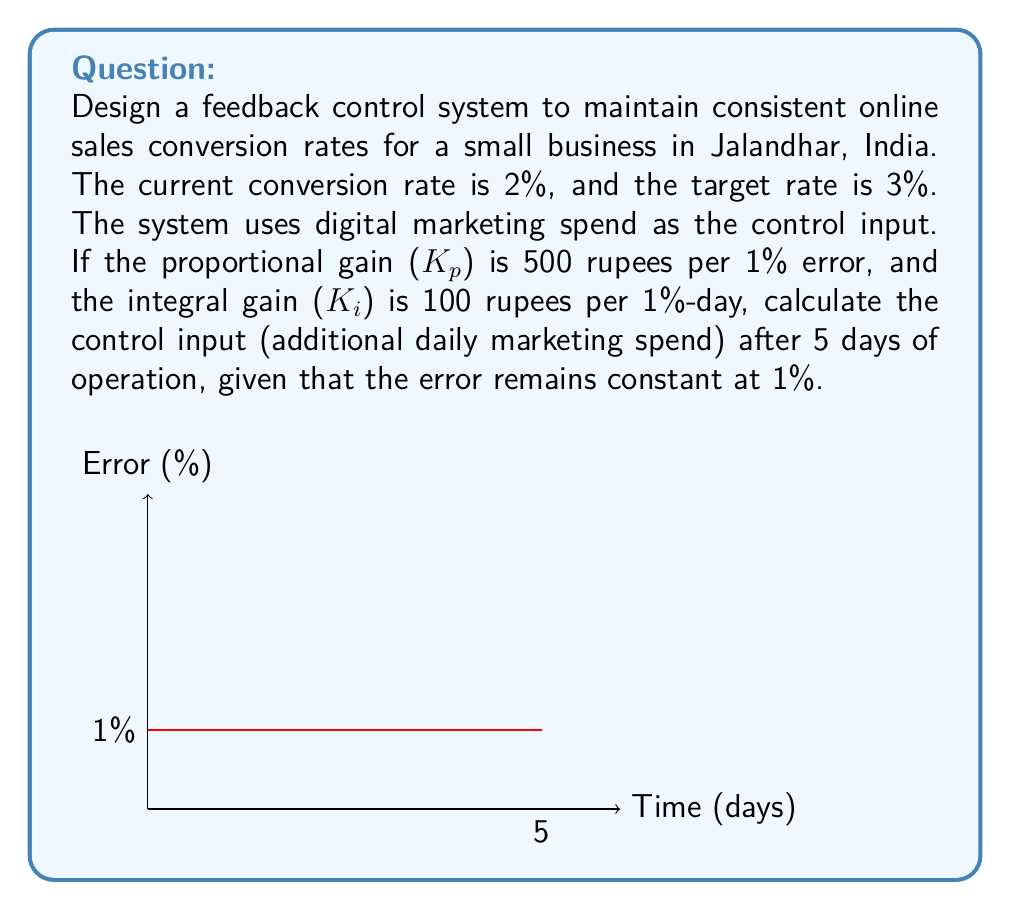Could you help me with this problem? To solve this problem, we'll use the principles of a PI (Proportional-Integral) controller in our feedback control system. The control input u(t) is given by:

$$u(t) = K_p \cdot e(t) + K_i \int_0^t e(\tau) d\tau$$

Where:
- $K_p$ is the proportional gain
- $K_i$ is the integral gain
- $e(t)$ is the error at time t

Given:
- $K_p = 500$ rupees per 1% error
- $K_i = 100$ rupees per 1%-day
- Error is constant at 1% for 5 days

Step 1: Calculate the proportional term
$$u_p = K_p \cdot e = 500 \cdot 1\% = 500 \text{ rupees}$$

Step 2: Calculate the integral term
Since the error is constant, we can simplify the integral:
$$u_i = K_i \int_0^t e(\tau) d\tau = K_i \cdot e \cdot t = 100 \cdot 1\% \cdot 5 \text{ days} = 500 \text{ rupees}$$

Step 3: Sum the proportional and integral terms
$$u(5) = u_p + u_i = 500 + 500 = 1000 \text{ rupees}$$

Therefore, after 5 days, the control system will add 1000 rupees to the daily marketing spend to correct the error in conversion rate.
Answer: 1000 rupees 